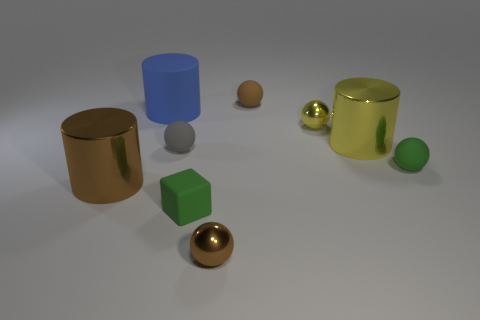Which item seems to have the roughest texture? The green cube appears to have the roughest texture among the items. The surface of the cube does not reflect light as strongly as the smoother metallic objects, indicating a less polished and more textured finish. 